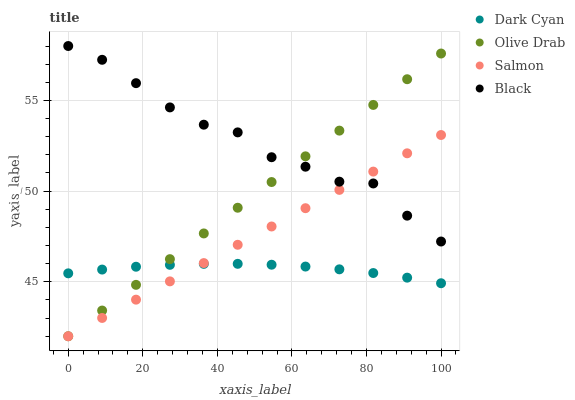Does Dark Cyan have the minimum area under the curve?
Answer yes or no. Yes. Does Black have the maximum area under the curve?
Answer yes or no. Yes. Does Salmon have the minimum area under the curve?
Answer yes or no. No. Does Salmon have the maximum area under the curve?
Answer yes or no. No. Is Olive Drab the smoothest?
Answer yes or no. Yes. Is Black the roughest?
Answer yes or no. Yes. Is Salmon the smoothest?
Answer yes or no. No. Is Salmon the roughest?
Answer yes or no. No. Does Salmon have the lowest value?
Answer yes or no. Yes. Does Black have the lowest value?
Answer yes or no. No. Does Black have the highest value?
Answer yes or no. Yes. Does Salmon have the highest value?
Answer yes or no. No. Is Dark Cyan less than Black?
Answer yes or no. Yes. Is Black greater than Dark Cyan?
Answer yes or no. Yes. Does Olive Drab intersect Black?
Answer yes or no. Yes. Is Olive Drab less than Black?
Answer yes or no. No. Is Olive Drab greater than Black?
Answer yes or no. No. Does Dark Cyan intersect Black?
Answer yes or no. No. 